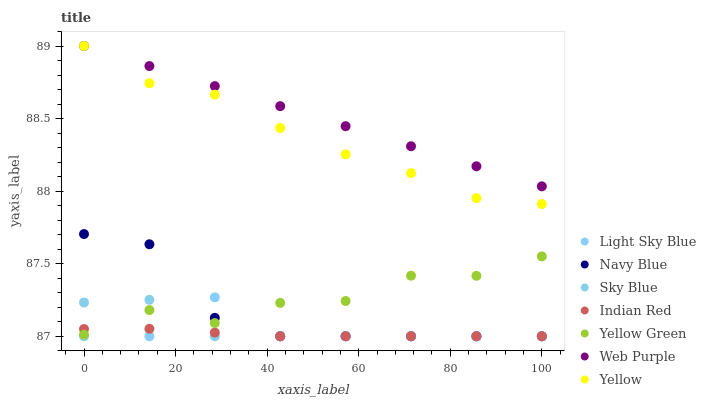Does Indian Red have the minimum area under the curve?
Answer yes or no. Yes. Does Web Purple have the maximum area under the curve?
Answer yes or no. Yes. Does Navy Blue have the minimum area under the curve?
Answer yes or no. No. Does Navy Blue have the maximum area under the curve?
Answer yes or no. No. Is Web Purple the smoothest?
Answer yes or no. Yes. Is Yellow Green the roughest?
Answer yes or no. Yes. Is Navy Blue the smoothest?
Answer yes or no. No. Is Navy Blue the roughest?
Answer yes or no. No. Does Navy Blue have the lowest value?
Answer yes or no. Yes. Does Yellow have the lowest value?
Answer yes or no. No. Does Web Purple have the highest value?
Answer yes or no. Yes. Does Navy Blue have the highest value?
Answer yes or no. No. Is Yellow Green less than Web Purple?
Answer yes or no. Yes. Is Yellow greater than Navy Blue?
Answer yes or no. Yes. Does Web Purple intersect Yellow?
Answer yes or no. Yes. Is Web Purple less than Yellow?
Answer yes or no. No. Is Web Purple greater than Yellow?
Answer yes or no. No. Does Yellow Green intersect Web Purple?
Answer yes or no. No. 